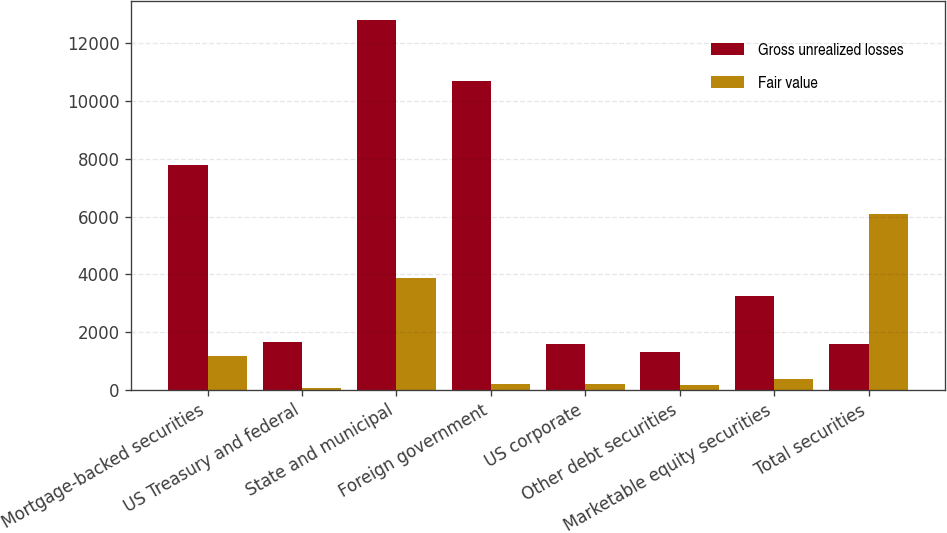<chart> <loc_0><loc_0><loc_500><loc_500><stacked_bar_chart><ecel><fcel>Mortgage-backed securities<fcel>US Treasury and federal<fcel>State and municipal<fcel>Foreign government<fcel>US corporate<fcel>Other debt securities<fcel>Marketable equity securities<fcel>Total securities<nl><fcel>Gross unrealized losses<fcel>7800<fcel>1654<fcel>12827<fcel>10697<fcel>1604<fcel>1325<fcel>3254<fcel>1604<nl><fcel>Fair value<fcel>1177<fcel>76<fcel>3872<fcel>201<fcel>214<fcel>152<fcel>386<fcel>6078<nl></chart> 